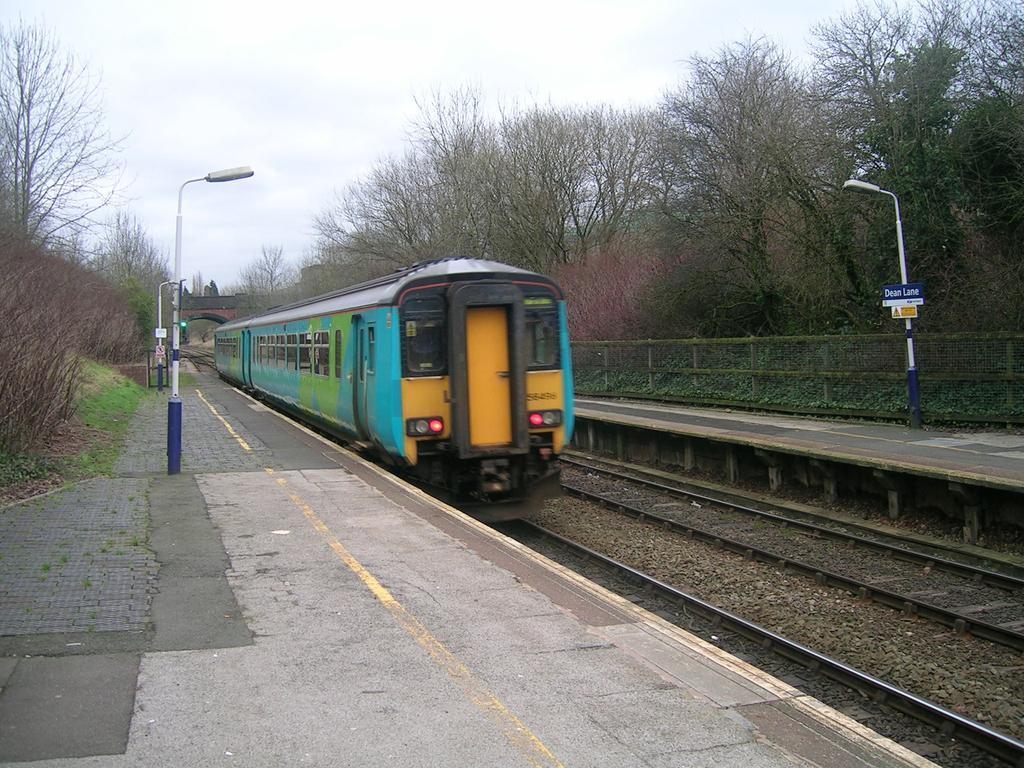In one or two sentences, can you explain what this image depicts? In this picture I can see there is a train moving on the track and there is a another track here and there are few poles with lights and there are plants and trees and there is a bridge in the backdrop and the sky is clear. 